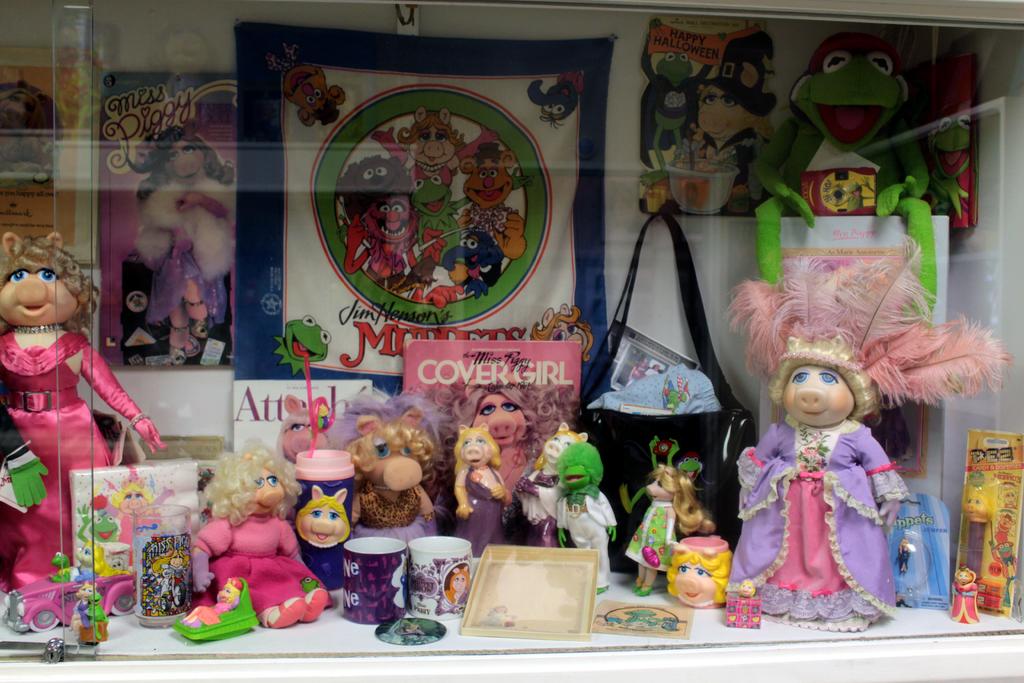What makeup brand is shown?
Make the answer very short. Covergirl. 